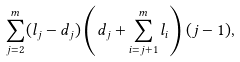<formula> <loc_0><loc_0><loc_500><loc_500>\sum _ { j = 2 } ^ { m } ( l _ { j } - d _ { j } ) \left ( d _ { j } + \sum _ { i = j + 1 } ^ { m } l _ { i } \right ) ( j - 1 ) ,</formula> 